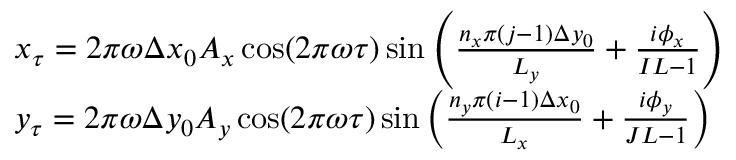Convert formula to latex. <formula><loc_0><loc_0><loc_500><loc_500>\begin{array} { r l } & { x _ { \tau } = 2 \pi \omega \Delta x _ { 0 } A _ { x } \cos ( 2 \pi \omega \tau ) \sin \left ( \frac { n _ { x } \pi ( j - 1 ) \Delta y _ { 0 } } { L _ { y } } + \frac { i \phi _ { x } } { I L - 1 } \right ) } \\ & { y _ { \tau } = 2 \pi \omega \Delta y _ { 0 } A _ { y } \cos ( 2 \pi \omega \tau ) \sin \left ( \frac { n _ { y } \pi ( i - 1 ) \Delta x _ { 0 } } { L _ { x } } + \frac { i \phi _ { y } } { J L - 1 } \right ) } \end{array}</formula> 